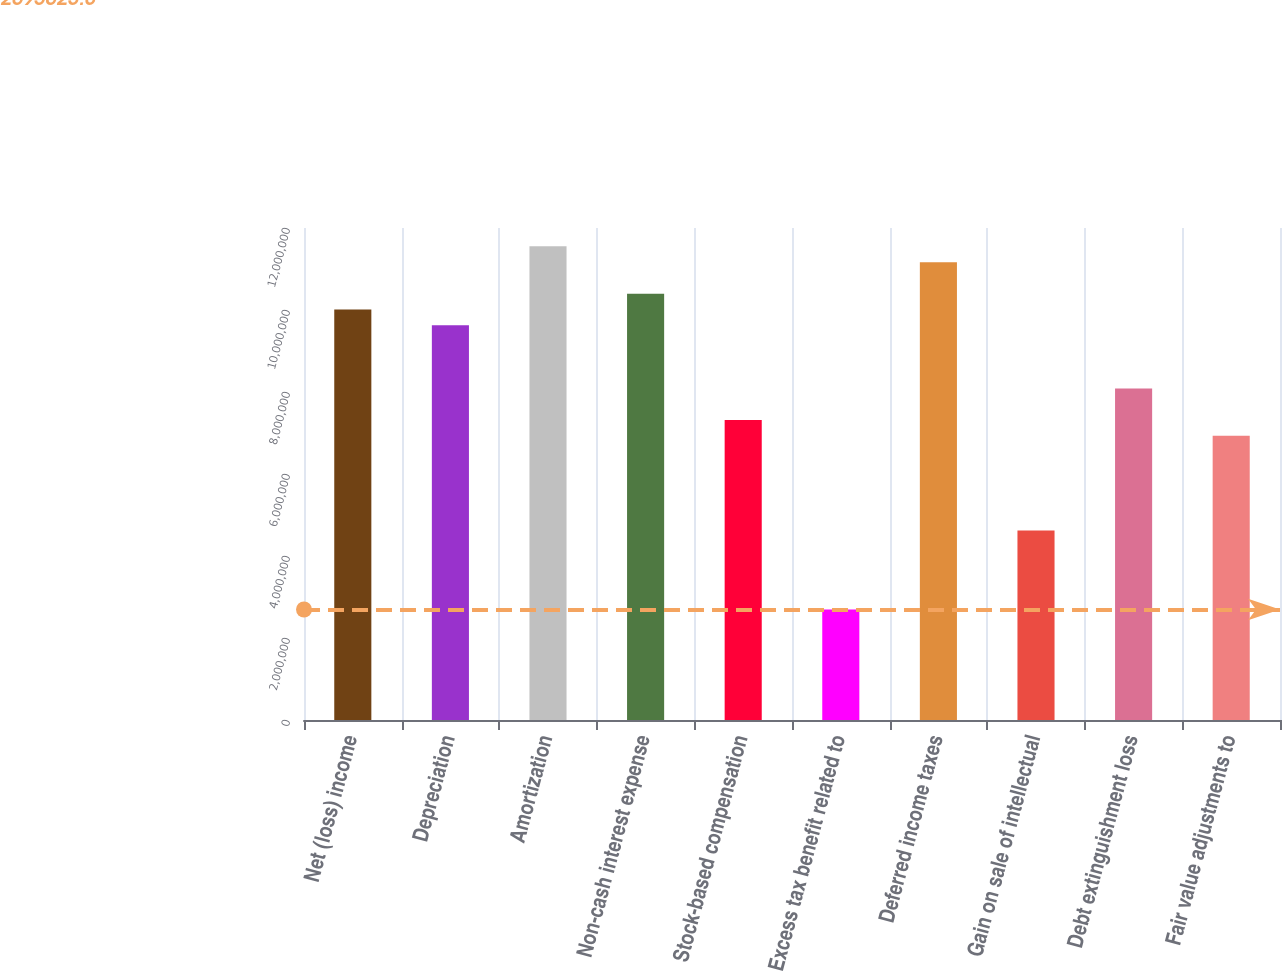Convert chart to OTSL. <chart><loc_0><loc_0><loc_500><loc_500><bar_chart><fcel>Net (loss) income<fcel>Depreciation<fcel>Amortization<fcel>Non-cash interest expense<fcel>Stock-based compensation<fcel>Excess tax benefit related to<fcel>Deferred income taxes<fcel>Gain on sale of intellectual<fcel>Debt extinguishment loss<fcel>Fair value adjustments to<nl><fcel>1.00116e+07<fcel>9.62658e+06<fcel>1.15519e+07<fcel>1.03967e+07<fcel>7.31626e+06<fcel>2.69562e+06<fcel>1.11668e+07<fcel>4.62089e+06<fcel>8.08637e+06<fcel>6.93121e+06<nl></chart> 